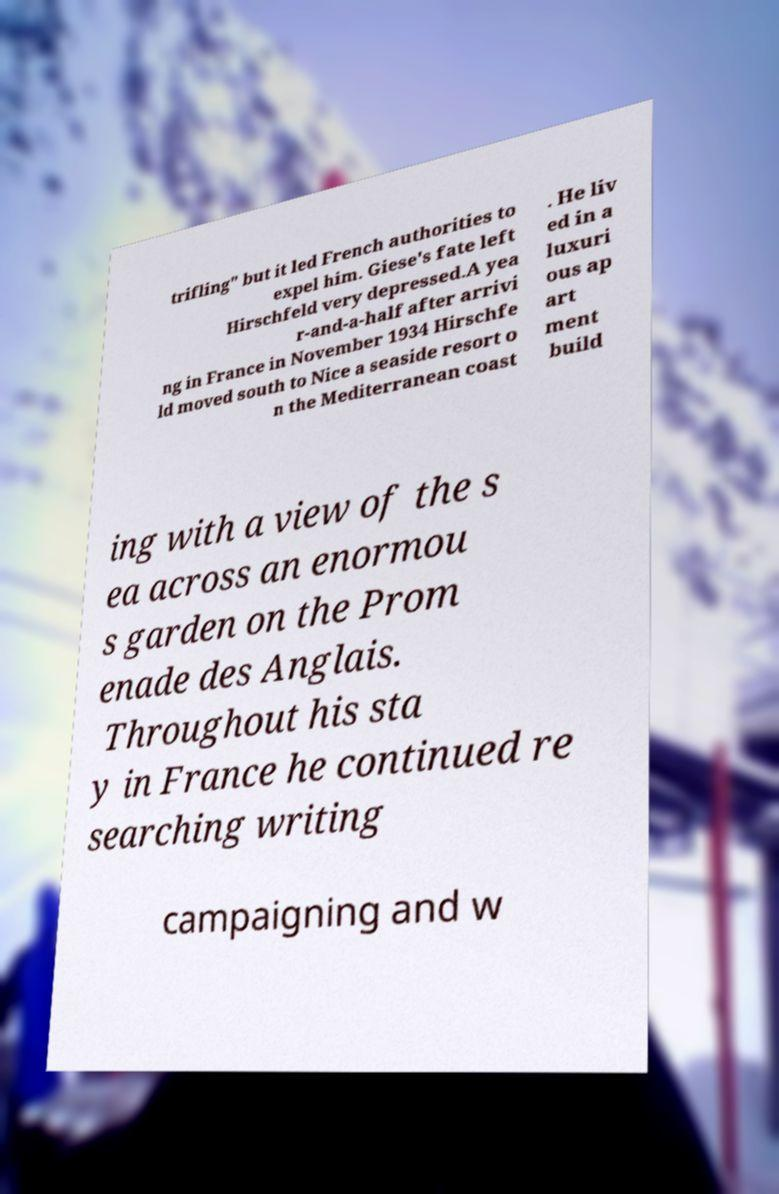I need the written content from this picture converted into text. Can you do that? trifling" but it led French authorities to expel him. Giese's fate left Hirschfeld very depressed.A yea r-and-a-half after arrivi ng in France in November 1934 Hirschfe ld moved south to Nice a seaside resort o n the Mediterranean coast . He liv ed in a luxuri ous ap art ment build ing with a view of the s ea across an enormou s garden on the Prom enade des Anglais. Throughout his sta y in France he continued re searching writing campaigning and w 